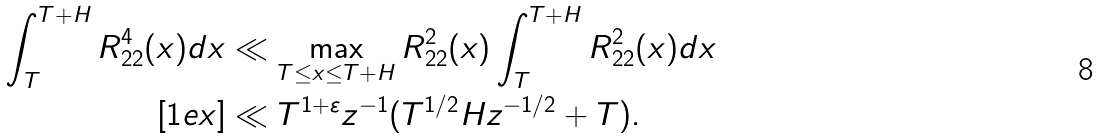Convert formula to latex. <formula><loc_0><loc_0><loc_500><loc_500>\int _ { T } ^ { T + H } R _ { 2 2 } ^ { 4 } ( x ) d x & \ll \max _ { T \leq x \leq T + H } R _ { 2 2 } ^ { 2 } ( x ) \int _ { T } ^ { T + H } R _ { 2 2 } ^ { 2 } ( x ) d x \\ [ 1 e x ] & \ll T ^ { 1 + \varepsilon } z ^ { - 1 } ( T ^ { 1 / 2 } H z ^ { - 1 / 2 } + T ) .</formula> 